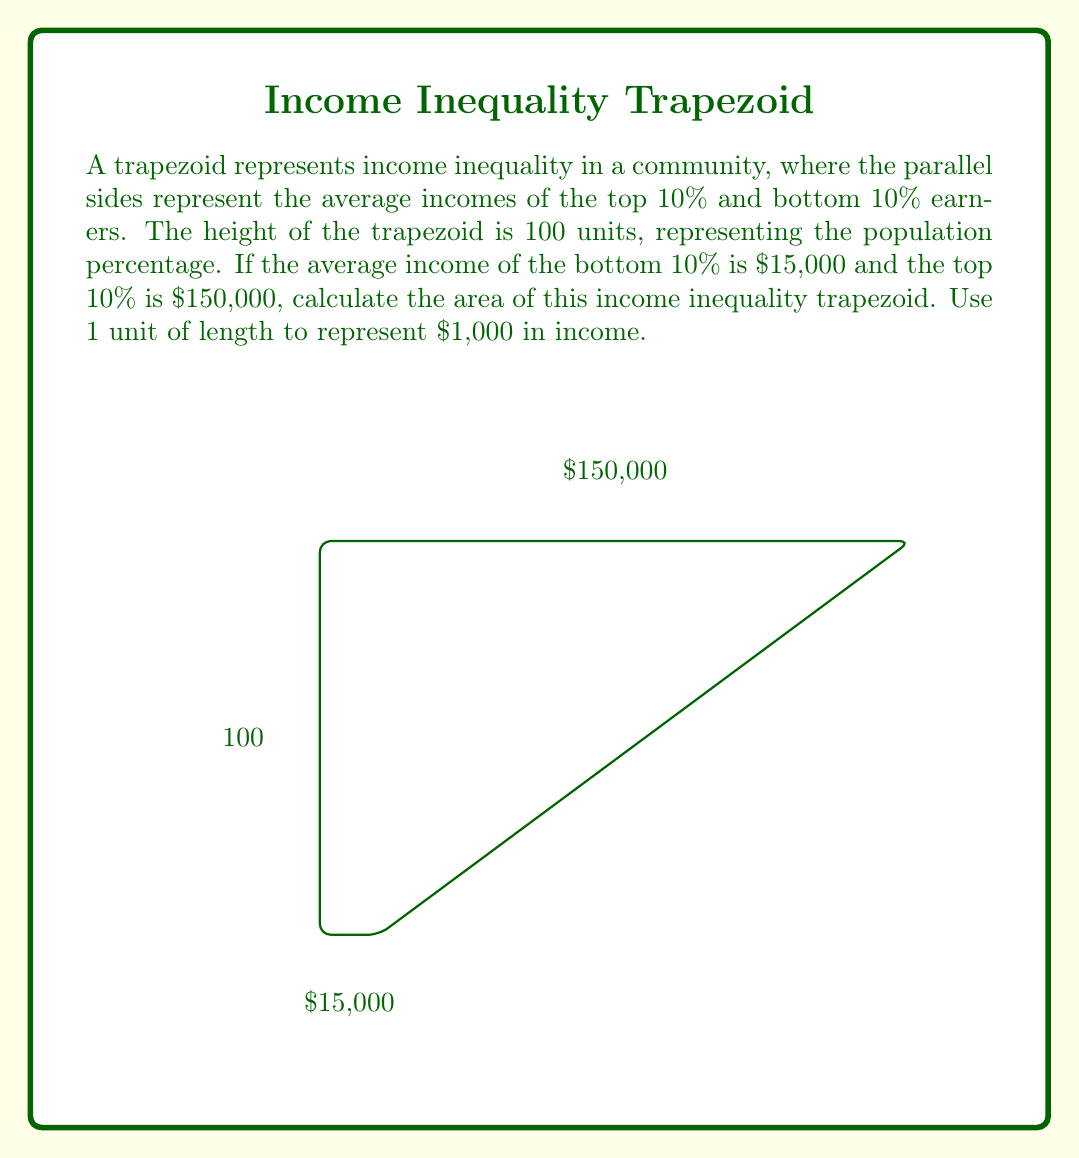Could you help me with this problem? Let's approach this step-by-step:

1) The formula for the area of a trapezoid is:
   $$A = \frac{1}{2}(b_1 + b_2)h$$
   where $A$ is the area, $b_1$ and $b_2$ are the lengths of the parallel sides, and $h$ is the height.

2) In this case:
   $b_1 = 15$ units (representing $15,000)
   $b_2 = 150$ units (representing $150,000)
   $h = 100$ units

3) Substituting these values into the formula:
   $$A = \frac{1}{2}(15 + 150) \times 100$$

4) Simplify inside the parentheses:
   $$A = \frac{1}{2}(165) \times 100$$

5) Multiply:
   $$A = 82.5 \times 100$$

6) Calculate the final result:
   $$A = 8,250$$

7) Since each unit represents $1,000 in income, the actual area represents $8,250,000.

This area represents the total income of the population if it were distributed equally between the top and bottom 10% earners.
Answer: 8,250 square units (representing $8,250,000) 